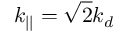Convert formula to latex. <formula><loc_0><loc_0><loc_500><loc_500>k _ { | | } = \sqrt { 2 } k _ { d }</formula> 